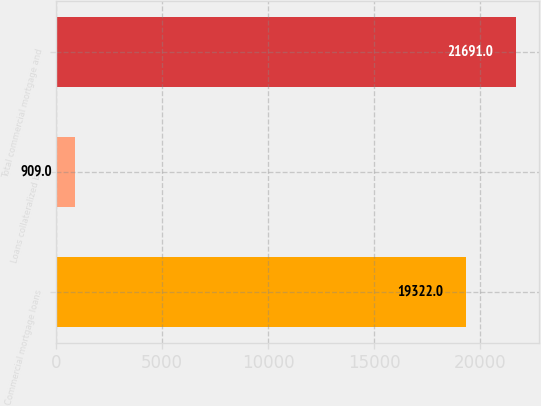Convert chart to OTSL. <chart><loc_0><loc_0><loc_500><loc_500><bar_chart><fcel>Commercial mortgage loans<fcel>Loans collateralized by<fcel>Total commercial mortgage and<nl><fcel>19322<fcel>909<fcel>21691<nl></chart> 